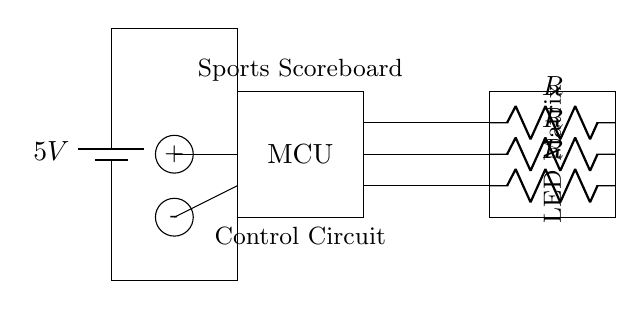What is the voltage of this circuit? The voltage is five volts, which is indicated next to the battery symbol, showing the power supply for the circuit.
Answer: five volts What does the rectangle labeled "MCU" represent? The rectangle labeled "MCU" represents the microcontroller, which is responsible for controlling the operations of the circuit, including the LEDs.
Answer: microcontroller How many LEDs are in the circuit? There are three LED connections depicted in the circuit diagram, indicated by the three lines leading to the LED matrix.
Answer: three What is the purpose of the resistors connected to the LEDs? The resistors are used to limit the current flowing through the LEDs, preventing them from burning out due to excessive current. This is a common practice in LED circuits.
Answer: limit current What are the two input buttons labeled as? The input buttons are labeled "+" for incrementing the score and "-" for decrementing the score, which allows users to interact with the scoreboard.
Answer: plus and minus How does the power supply connect to the microcontroller? The power supply connects to the microcontroller through a series of lines shown in the diagram, indicating that voltage from the battery goes directly into the microcontroller for operation.
Answer: through direct lines 